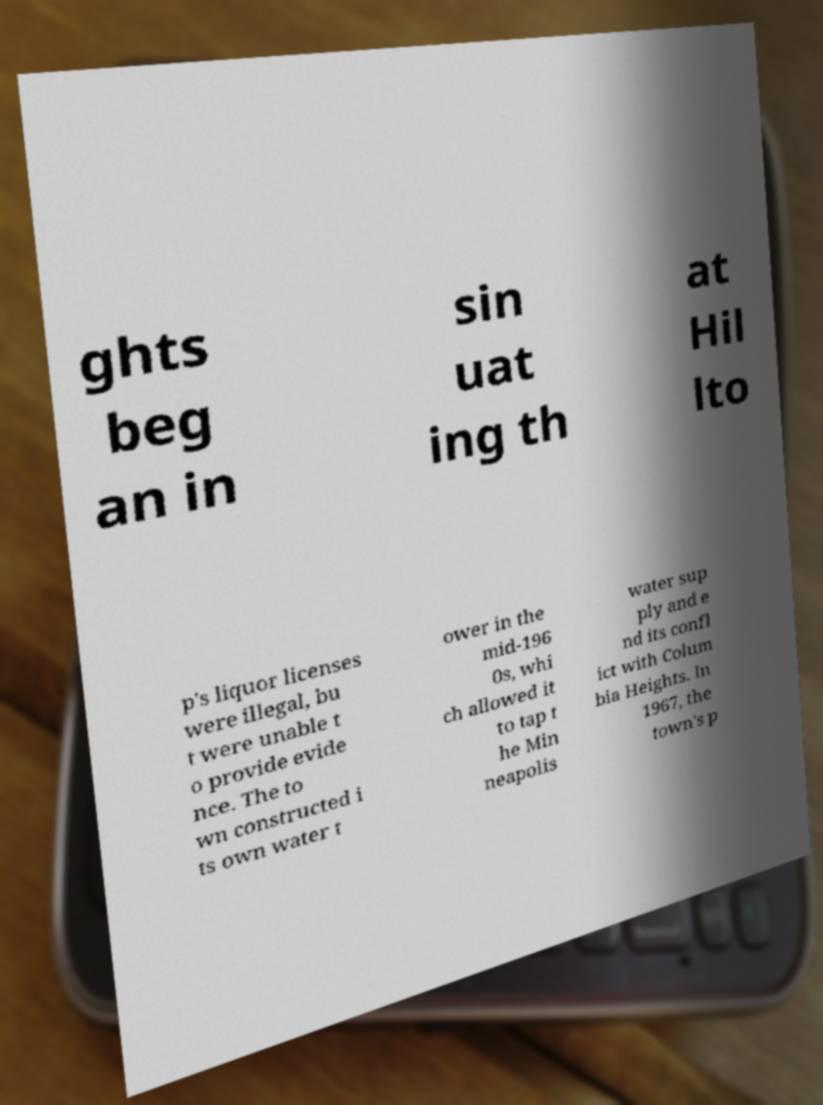Can you accurately transcribe the text from the provided image for me? ghts beg an in sin uat ing th at Hil lto p's liquor licenses were illegal, bu t were unable t o provide evide nce. The to wn constructed i ts own water t ower in the mid-196 0s, whi ch allowed it to tap t he Min neapolis water sup ply and e nd its confl ict with Colum bia Heights. In 1967, the town's p 